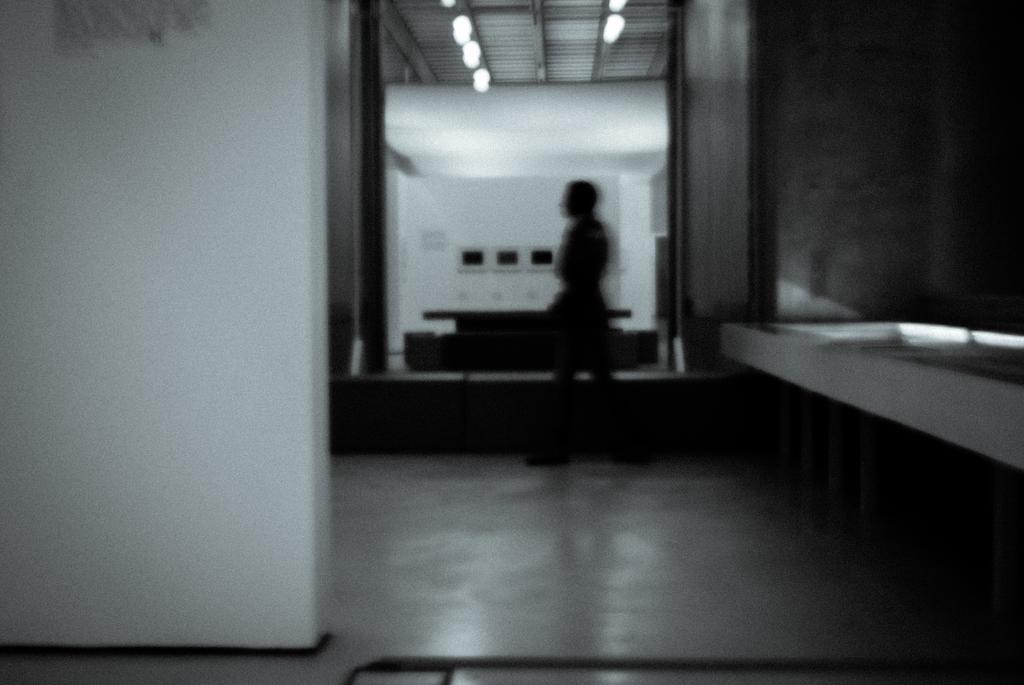How would you summarize this image in a sentence or two? In this image in the middle there is a person. At the bottom there is a floor. This image is clicked inside a building. In the background there are lights, table, wall. 